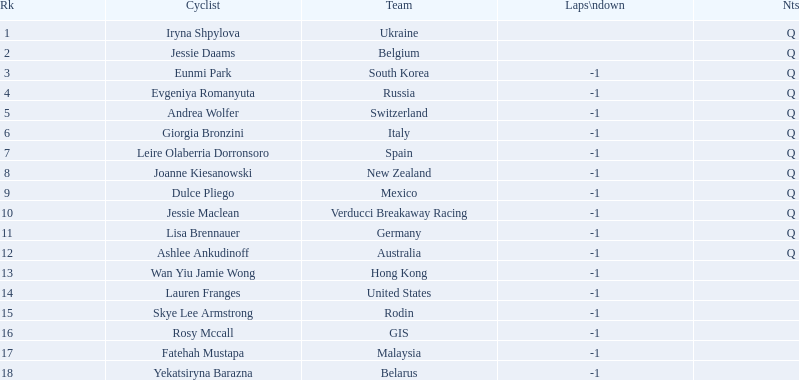Who are all of the cyclists in this race? Iryna Shpylova, Jessie Daams, Eunmi Park, Evgeniya Romanyuta, Andrea Wolfer, Giorgia Bronzini, Leire Olaberria Dorronsoro, Joanne Kiesanowski, Dulce Pliego, Jessie Maclean, Lisa Brennauer, Ashlee Ankudinoff, Wan Yiu Jamie Wong, Lauren Franges, Skye Lee Armstrong, Rosy Mccall, Fatehah Mustapa, Yekatsiryna Barazna. Of these, which one has the lowest numbered rank? Iryna Shpylova. 